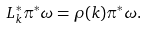Convert formula to latex. <formula><loc_0><loc_0><loc_500><loc_500>L _ { k } ^ { * } \pi ^ { * } \omega = \rho ( k ) \pi ^ { * } \omega .</formula> 